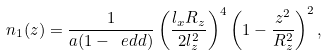Convert formula to latex. <formula><loc_0><loc_0><loc_500><loc_500>n _ { 1 } ( z ) = \frac { 1 } { a ( 1 - \ e d d ) } \left ( \frac { l _ { x } R _ { z } } { 2 l _ { z } ^ { 2 } } \right ) ^ { 4 } \left ( 1 - \frac { z ^ { 2 } } { R _ { z } ^ { 2 } } \right ) ^ { 2 } ,</formula> 